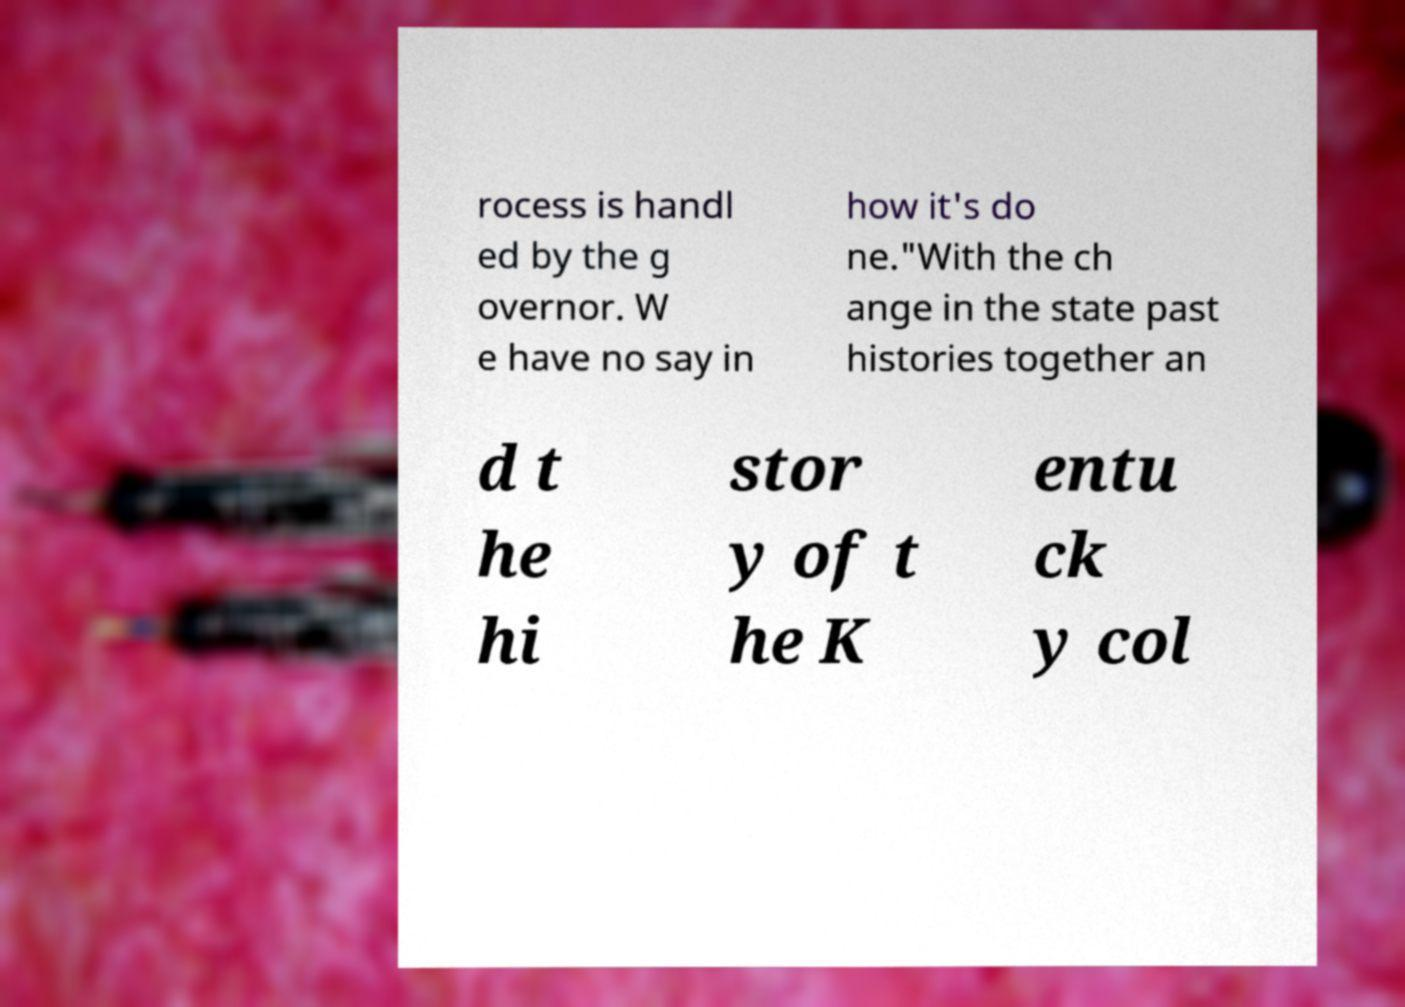Could you assist in decoding the text presented in this image and type it out clearly? rocess is handl ed by the g overnor. W e have no say in how it's do ne."With the ch ange in the state past histories together an d t he hi stor y of t he K entu ck y col 